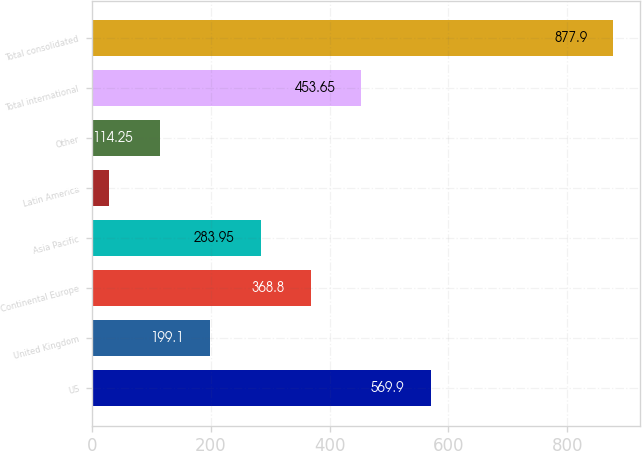Convert chart to OTSL. <chart><loc_0><loc_0><loc_500><loc_500><bar_chart><fcel>US<fcel>United Kingdom<fcel>Continental Europe<fcel>Asia Pacific<fcel>Latin America<fcel>Other<fcel>Total international<fcel>Total consolidated<nl><fcel>569.9<fcel>199.1<fcel>368.8<fcel>283.95<fcel>29.4<fcel>114.25<fcel>453.65<fcel>877.9<nl></chart> 